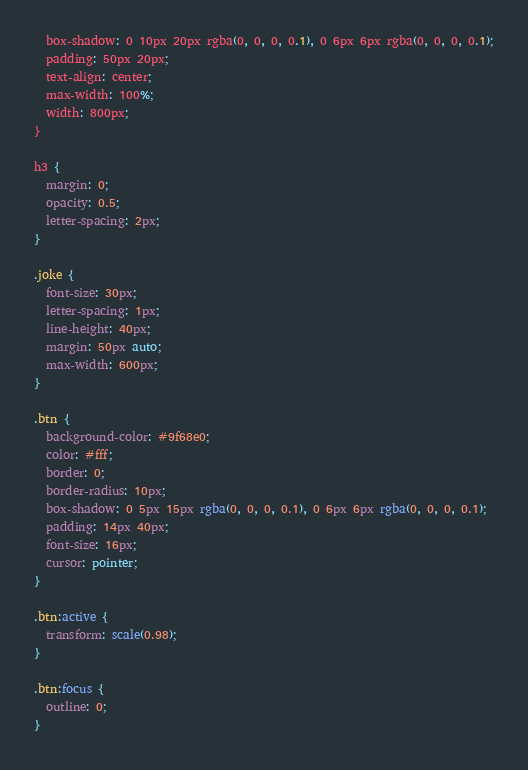Convert code to text. <code><loc_0><loc_0><loc_500><loc_500><_CSS_>  box-shadow: 0 10px 20px rgba(0, 0, 0, 0.1), 0 6px 6px rgba(0, 0, 0, 0.1);
  padding: 50px 20px;
  text-align: center;
  max-width: 100%;
  width: 800px;
}

h3 {
  margin: 0;
  opacity: 0.5;
  letter-spacing: 2px;
}

.joke {
  font-size: 30px;
  letter-spacing: 1px;
  line-height: 40px;
  margin: 50px auto;
  max-width: 600px;
}

.btn {
  background-color: #9f68e0;
  color: #fff;
  border: 0;
  border-radius: 10px;
  box-shadow: 0 5px 15px rgba(0, 0, 0, 0.1), 0 6px 6px rgba(0, 0, 0, 0.1);
  padding: 14px 40px;
  font-size: 16px;
  cursor: pointer;
}

.btn:active {
  transform: scale(0.98);
}

.btn:focus {
  outline: 0;
}
</code> 